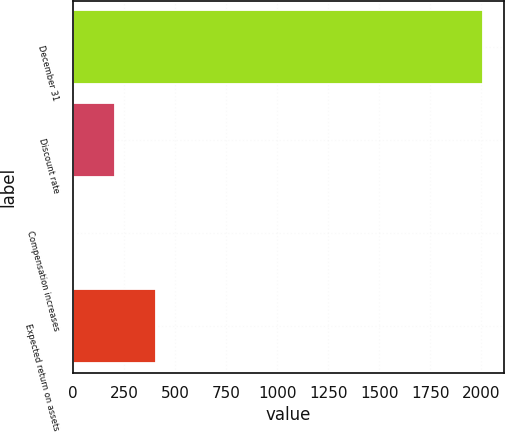Convert chart. <chart><loc_0><loc_0><loc_500><loc_500><bar_chart><fcel>December 31<fcel>Discount rate<fcel>Compensation increases<fcel>Expected return on assets<nl><fcel>2010<fcel>205<fcel>4.44<fcel>405.56<nl></chart> 